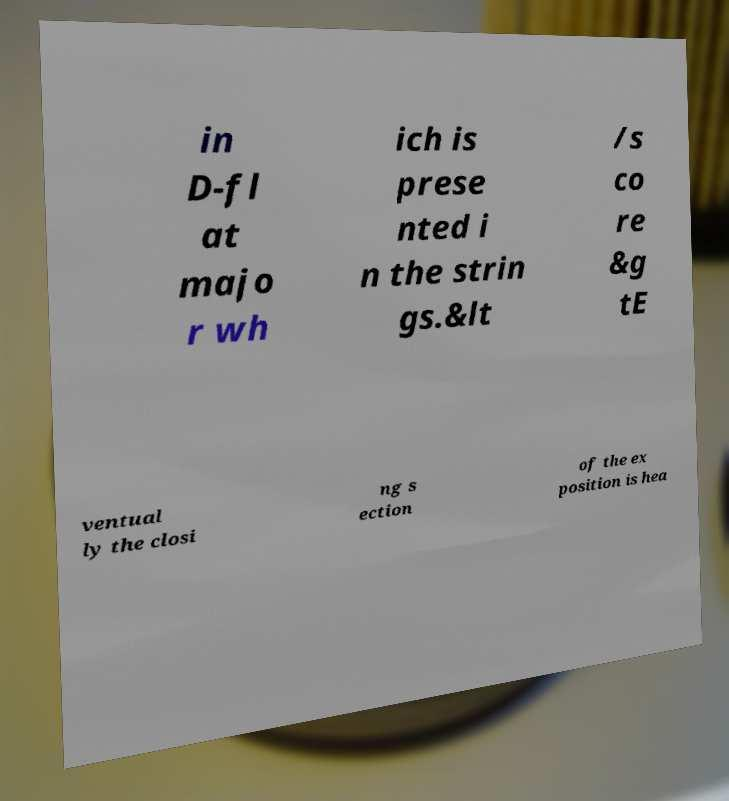Can you accurately transcribe the text from the provided image for me? in D-fl at majo r wh ich is prese nted i n the strin gs.&lt /s co re &g tE ventual ly the closi ng s ection of the ex position is hea 